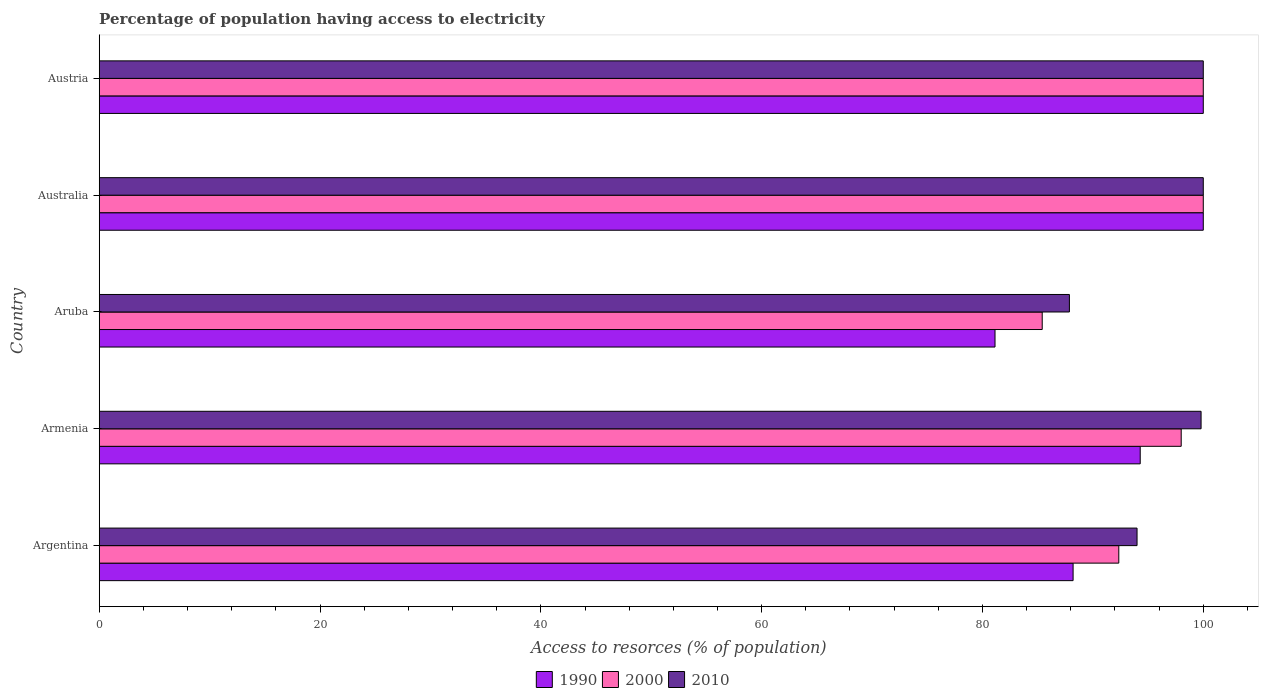How many different coloured bars are there?
Provide a succinct answer. 3. Are the number of bars on each tick of the Y-axis equal?
Offer a terse response. Yes. How many bars are there on the 5th tick from the top?
Your response must be concise. 3. How many bars are there on the 4th tick from the bottom?
Offer a terse response. 3. What is the label of the 4th group of bars from the top?
Your response must be concise. Armenia. What is the percentage of population having access to electricity in 2010 in Aruba?
Offer a terse response. 87.87. Across all countries, what is the minimum percentage of population having access to electricity in 1990?
Offer a very short reply. 81.14. In which country was the percentage of population having access to electricity in 1990 minimum?
Your answer should be compact. Aruba. What is the total percentage of population having access to electricity in 2000 in the graph?
Ensure brevity in your answer.  475.76. What is the difference between the percentage of population having access to electricity in 1990 in Argentina and that in Austria?
Ensure brevity in your answer.  -11.79. What is the difference between the percentage of population having access to electricity in 2010 in Aruba and the percentage of population having access to electricity in 1990 in Austria?
Give a very brief answer. -12.13. What is the average percentage of population having access to electricity in 1990 per country?
Keep it short and to the point. 92.73. What is the difference between the percentage of population having access to electricity in 2000 and percentage of population having access to electricity in 2010 in Argentina?
Offer a very short reply. -1.65. Is the difference between the percentage of population having access to electricity in 2000 in Armenia and Australia greater than the difference between the percentage of population having access to electricity in 2010 in Armenia and Australia?
Your answer should be very brief. No. What is the difference between the highest and the lowest percentage of population having access to electricity in 1990?
Make the answer very short. 18.86. In how many countries, is the percentage of population having access to electricity in 1990 greater than the average percentage of population having access to electricity in 1990 taken over all countries?
Offer a very short reply. 3. Is the sum of the percentage of population having access to electricity in 2000 in Argentina and Armenia greater than the maximum percentage of population having access to electricity in 1990 across all countries?
Your answer should be compact. Yes. What does the 2nd bar from the top in Aruba represents?
Ensure brevity in your answer.  2000. Is it the case that in every country, the sum of the percentage of population having access to electricity in 2010 and percentage of population having access to electricity in 1990 is greater than the percentage of population having access to electricity in 2000?
Your answer should be very brief. Yes. What is the difference between two consecutive major ticks on the X-axis?
Make the answer very short. 20. Does the graph contain grids?
Keep it short and to the point. No. Where does the legend appear in the graph?
Give a very brief answer. Bottom center. How are the legend labels stacked?
Make the answer very short. Horizontal. What is the title of the graph?
Your response must be concise. Percentage of population having access to electricity. Does "1966" appear as one of the legend labels in the graph?
Offer a terse response. No. What is the label or title of the X-axis?
Keep it short and to the point. Access to resorces (% of population). What is the label or title of the Y-axis?
Offer a terse response. Country. What is the Access to resorces (% of population) in 1990 in Argentina?
Your answer should be very brief. 88.21. What is the Access to resorces (% of population) of 2000 in Argentina?
Offer a very short reply. 92.35. What is the Access to resorces (% of population) of 2010 in Argentina?
Provide a short and direct response. 94. What is the Access to resorces (% of population) of 1990 in Armenia?
Provide a short and direct response. 94.29. What is the Access to resorces (% of population) in 2000 in Armenia?
Keep it short and to the point. 98. What is the Access to resorces (% of population) in 2010 in Armenia?
Provide a succinct answer. 99.8. What is the Access to resorces (% of population) in 1990 in Aruba?
Ensure brevity in your answer.  81.14. What is the Access to resorces (% of population) in 2000 in Aruba?
Your answer should be very brief. 85.41. What is the Access to resorces (% of population) of 2010 in Aruba?
Give a very brief answer. 87.87. What is the Access to resorces (% of population) of 2000 in Australia?
Your response must be concise. 100. What is the Access to resorces (% of population) in 1990 in Austria?
Make the answer very short. 100. What is the Access to resorces (% of population) of 2000 in Austria?
Offer a very short reply. 100. Across all countries, what is the maximum Access to resorces (% of population) in 1990?
Offer a terse response. 100. Across all countries, what is the maximum Access to resorces (% of population) in 2000?
Offer a terse response. 100. Across all countries, what is the minimum Access to resorces (% of population) of 1990?
Offer a terse response. 81.14. Across all countries, what is the minimum Access to resorces (% of population) of 2000?
Make the answer very short. 85.41. Across all countries, what is the minimum Access to resorces (% of population) in 2010?
Give a very brief answer. 87.87. What is the total Access to resorces (% of population) in 1990 in the graph?
Keep it short and to the point. 463.63. What is the total Access to resorces (% of population) of 2000 in the graph?
Make the answer very short. 475.76. What is the total Access to resorces (% of population) of 2010 in the graph?
Offer a very short reply. 481.67. What is the difference between the Access to resorces (% of population) of 1990 in Argentina and that in Armenia?
Offer a terse response. -6.08. What is the difference between the Access to resorces (% of population) in 2000 in Argentina and that in Armenia?
Provide a short and direct response. -5.65. What is the difference between the Access to resorces (% of population) of 2010 in Argentina and that in Armenia?
Offer a very short reply. -5.8. What is the difference between the Access to resorces (% of population) in 1990 in Argentina and that in Aruba?
Offer a terse response. 7.07. What is the difference between the Access to resorces (% of population) in 2000 in Argentina and that in Aruba?
Offer a terse response. 6.94. What is the difference between the Access to resorces (% of population) in 2010 in Argentina and that in Aruba?
Offer a terse response. 6.13. What is the difference between the Access to resorces (% of population) of 1990 in Argentina and that in Australia?
Offer a very short reply. -11.79. What is the difference between the Access to resorces (% of population) of 2000 in Argentina and that in Australia?
Make the answer very short. -7.65. What is the difference between the Access to resorces (% of population) of 2010 in Argentina and that in Australia?
Ensure brevity in your answer.  -6. What is the difference between the Access to resorces (% of population) of 1990 in Argentina and that in Austria?
Give a very brief answer. -11.79. What is the difference between the Access to resorces (% of population) of 2000 in Argentina and that in Austria?
Keep it short and to the point. -7.65. What is the difference between the Access to resorces (% of population) in 1990 in Armenia and that in Aruba?
Your response must be concise. 13.15. What is the difference between the Access to resorces (% of population) in 2000 in Armenia and that in Aruba?
Provide a succinct answer. 12.59. What is the difference between the Access to resorces (% of population) of 2010 in Armenia and that in Aruba?
Make the answer very short. 11.93. What is the difference between the Access to resorces (% of population) in 1990 in Armenia and that in Australia?
Provide a short and direct response. -5.71. What is the difference between the Access to resorces (% of population) of 2010 in Armenia and that in Australia?
Offer a terse response. -0.2. What is the difference between the Access to resorces (% of population) in 1990 in Armenia and that in Austria?
Make the answer very short. -5.71. What is the difference between the Access to resorces (% of population) in 2010 in Armenia and that in Austria?
Ensure brevity in your answer.  -0.2. What is the difference between the Access to resorces (% of population) of 1990 in Aruba and that in Australia?
Offer a terse response. -18.86. What is the difference between the Access to resorces (% of population) in 2000 in Aruba and that in Australia?
Offer a terse response. -14.59. What is the difference between the Access to resorces (% of population) of 2010 in Aruba and that in Australia?
Your answer should be very brief. -12.13. What is the difference between the Access to resorces (% of population) of 1990 in Aruba and that in Austria?
Your answer should be very brief. -18.86. What is the difference between the Access to resorces (% of population) of 2000 in Aruba and that in Austria?
Offer a very short reply. -14.59. What is the difference between the Access to resorces (% of population) of 2010 in Aruba and that in Austria?
Keep it short and to the point. -12.13. What is the difference between the Access to resorces (% of population) in 2010 in Australia and that in Austria?
Ensure brevity in your answer.  0. What is the difference between the Access to resorces (% of population) of 1990 in Argentina and the Access to resorces (% of population) of 2000 in Armenia?
Provide a short and direct response. -9.79. What is the difference between the Access to resorces (% of population) of 1990 in Argentina and the Access to resorces (% of population) of 2010 in Armenia?
Your answer should be compact. -11.59. What is the difference between the Access to resorces (% of population) in 2000 in Argentina and the Access to resorces (% of population) in 2010 in Armenia?
Your answer should be very brief. -7.45. What is the difference between the Access to resorces (% of population) of 1990 in Argentina and the Access to resorces (% of population) of 2000 in Aruba?
Your answer should be compact. 2.8. What is the difference between the Access to resorces (% of population) of 1990 in Argentina and the Access to resorces (% of population) of 2010 in Aruba?
Offer a very short reply. 0.33. What is the difference between the Access to resorces (% of population) in 2000 in Argentina and the Access to resorces (% of population) in 2010 in Aruba?
Ensure brevity in your answer.  4.47. What is the difference between the Access to resorces (% of population) in 1990 in Argentina and the Access to resorces (% of population) in 2000 in Australia?
Provide a short and direct response. -11.79. What is the difference between the Access to resorces (% of population) of 1990 in Argentina and the Access to resorces (% of population) of 2010 in Australia?
Give a very brief answer. -11.79. What is the difference between the Access to resorces (% of population) in 2000 in Argentina and the Access to resorces (% of population) in 2010 in Australia?
Keep it short and to the point. -7.65. What is the difference between the Access to resorces (% of population) in 1990 in Argentina and the Access to resorces (% of population) in 2000 in Austria?
Your answer should be very brief. -11.79. What is the difference between the Access to resorces (% of population) of 1990 in Argentina and the Access to resorces (% of population) of 2010 in Austria?
Your response must be concise. -11.79. What is the difference between the Access to resorces (% of population) in 2000 in Argentina and the Access to resorces (% of population) in 2010 in Austria?
Provide a short and direct response. -7.65. What is the difference between the Access to resorces (% of population) of 1990 in Armenia and the Access to resorces (% of population) of 2000 in Aruba?
Your answer should be compact. 8.88. What is the difference between the Access to resorces (% of population) in 1990 in Armenia and the Access to resorces (% of population) in 2010 in Aruba?
Your answer should be compact. 6.41. What is the difference between the Access to resorces (% of population) in 2000 in Armenia and the Access to resorces (% of population) in 2010 in Aruba?
Keep it short and to the point. 10.13. What is the difference between the Access to resorces (% of population) of 1990 in Armenia and the Access to resorces (% of population) of 2000 in Australia?
Provide a succinct answer. -5.71. What is the difference between the Access to resorces (% of population) of 1990 in Armenia and the Access to resorces (% of population) of 2010 in Australia?
Make the answer very short. -5.71. What is the difference between the Access to resorces (% of population) in 2000 in Armenia and the Access to resorces (% of population) in 2010 in Australia?
Your answer should be very brief. -2. What is the difference between the Access to resorces (% of population) of 1990 in Armenia and the Access to resorces (% of population) of 2000 in Austria?
Your response must be concise. -5.71. What is the difference between the Access to resorces (% of population) of 1990 in Armenia and the Access to resorces (% of population) of 2010 in Austria?
Your answer should be very brief. -5.71. What is the difference between the Access to resorces (% of population) of 1990 in Aruba and the Access to resorces (% of population) of 2000 in Australia?
Provide a succinct answer. -18.86. What is the difference between the Access to resorces (% of population) of 1990 in Aruba and the Access to resorces (% of population) of 2010 in Australia?
Make the answer very short. -18.86. What is the difference between the Access to resorces (% of population) of 2000 in Aruba and the Access to resorces (% of population) of 2010 in Australia?
Offer a very short reply. -14.59. What is the difference between the Access to resorces (% of population) in 1990 in Aruba and the Access to resorces (% of population) in 2000 in Austria?
Your response must be concise. -18.86. What is the difference between the Access to resorces (% of population) in 1990 in Aruba and the Access to resorces (% of population) in 2010 in Austria?
Provide a short and direct response. -18.86. What is the difference between the Access to resorces (% of population) of 2000 in Aruba and the Access to resorces (% of population) of 2010 in Austria?
Keep it short and to the point. -14.59. What is the difference between the Access to resorces (% of population) in 1990 in Australia and the Access to resorces (% of population) in 2010 in Austria?
Your answer should be compact. 0. What is the average Access to resorces (% of population) of 1990 per country?
Your response must be concise. 92.73. What is the average Access to resorces (% of population) in 2000 per country?
Your response must be concise. 95.15. What is the average Access to resorces (% of population) in 2010 per country?
Your response must be concise. 96.33. What is the difference between the Access to resorces (% of population) of 1990 and Access to resorces (% of population) of 2000 in Argentina?
Your answer should be compact. -4.14. What is the difference between the Access to resorces (% of population) in 1990 and Access to resorces (% of population) in 2010 in Argentina?
Make the answer very short. -5.79. What is the difference between the Access to resorces (% of population) of 2000 and Access to resorces (% of population) of 2010 in Argentina?
Offer a very short reply. -1.65. What is the difference between the Access to resorces (% of population) in 1990 and Access to resorces (% of population) in 2000 in Armenia?
Your answer should be very brief. -3.71. What is the difference between the Access to resorces (% of population) in 1990 and Access to resorces (% of population) in 2010 in Armenia?
Your response must be concise. -5.51. What is the difference between the Access to resorces (% of population) of 2000 and Access to resorces (% of population) of 2010 in Armenia?
Offer a terse response. -1.8. What is the difference between the Access to resorces (% of population) in 1990 and Access to resorces (% of population) in 2000 in Aruba?
Offer a terse response. -4.28. What is the difference between the Access to resorces (% of population) of 1990 and Access to resorces (% of population) of 2010 in Aruba?
Offer a terse response. -6.74. What is the difference between the Access to resorces (% of population) in 2000 and Access to resorces (% of population) in 2010 in Aruba?
Provide a short and direct response. -2.46. What is the difference between the Access to resorces (% of population) in 1990 and Access to resorces (% of population) in 2010 in Australia?
Make the answer very short. 0. What is the difference between the Access to resorces (% of population) in 2000 and Access to resorces (% of population) in 2010 in Austria?
Give a very brief answer. 0. What is the ratio of the Access to resorces (% of population) of 1990 in Argentina to that in Armenia?
Provide a succinct answer. 0.94. What is the ratio of the Access to resorces (% of population) in 2000 in Argentina to that in Armenia?
Offer a very short reply. 0.94. What is the ratio of the Access to resorces (% of population) in 2010 in Argentina to that in Armenia?
Your response must be concise. 0.94. What is the ratio of the Access to resorces (% of population) of 1990 in Argentina to that in Aruba?
Your answer should be very brief. 1.09. What is the ratio of the Access to resorces (% of population) of 2000 in Argentina to that in Aruba?
Your response must be concise. 1.08. What is the ratio of the Access to resorces (% of population) in 2010 in Argentina to that in Aruba?
Provide a short and direct response. 1.07. What is the ratio of the Access to resorces (% of population) in 1990 in Argentina to that in Australia?
Provide a short and direct response. 0.88. What is the ratio of the Access to resorces (% of population) in 2000 in Argentina to that in Australia?
Your answer should be compact. 0.92. What is the ratio of the Access to resorces (% of population) in 1990 in Argentina to that in Austria?
Your answer should be compact. 0.88. What is the ratio of the Access to resorces (% of population) in 2000 in Argentina to that in Austria?
Provide a short and direct response. 0.92. What is the ratio of the Access to resorces (% of population) in 1990 in Armenia to that in Aruba?
Your response must be concise. 1.16. What is the ratio of the Access to resorces (% of population) of 2000 in Armenia to that in Aruba?
Your response must be concise. 1.15. What is the ratio of the Access to resorces (% of population) in 2010 in Armenia to that in Aruba?
Your answer should be very brief. 1.14. What is the ratio of the Access to resorces (% of population) in 1990 in Armenia to that in Australia?
Make the answer very short. 0.94. What is the ratio of the Access to resorces (% of population) of 1990 in Armenia to that in Austria?
Ensure brevity in your answer.  0.94. What is the ratio of the Access to resorces (% of population) of 2000 in Armenia to that in Austria?
Ensure brevity in your answer.  0.98. What is the ratio of the Access to resorces (% of population) in 1990 in Aruba to that in Australia?
Your answer should be compact. 0.81. What is the ratio of the Access to resorces (% of population) in 2000 in Aruba to that in Australia?
Offer a terse response. 0.85. What is the ratio of the Access to resorces (% of population) in 2010 in Aruba to that in Australia?
Your answer should be compact. 0.88. What is the ratio of the Access to resorces (% of population) of 1990 in Aruba to that in Austria?
Your answer should be compact. 0.81. What is the ratio of the Access to resorces (% of population) of 2000 in Aruba to that in Austria?
Your answer should be very brief. 0.85. What is the ratio of the Access to resorces (% of population) in 2010 in Aruba to that in Austria?
Your answer should be very brief. 0.88. What is the ratio of the Access to resorces (% of population) of 1990 in Australia to that in Austria?
Your answer should be compact. 1. What is the ratio of the Access to resorces (% of population) in 2000 in Australia to that in Austria?
Your response must be concise. 1. What is the difference between the highest and the second highest Access to resorces (% of population) of 2000?
Keep it short and to the point. 0. What is the difference between the highest and the lowest Access to resorces (% of population) in 1990?
Give a very brief answer. 18.86. What is the difference between the highest and the lowest Access to resorces (% of population) in 2000?
Offer a very short reply. 14.59. What is the difference between the highest and the lowest Access to resorces (% of population) of 2010?
Make the answer very short. 12.13. 